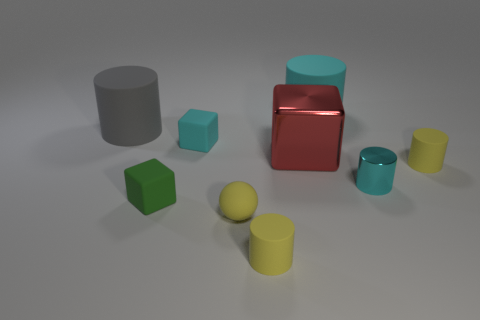What might be the function of these objects if they were found in a real-life setting? In a real-life setting, these objects could serve as simplistic models or prototypes for various products. The cylindrical and cuboid shapes might represent containers, vases, or storage elements, while the spheres could be decorative or part of a game like table tennis. Their primary function seems to be educational or demonstrative, showcasing geometric forms and contrasts in colors. 